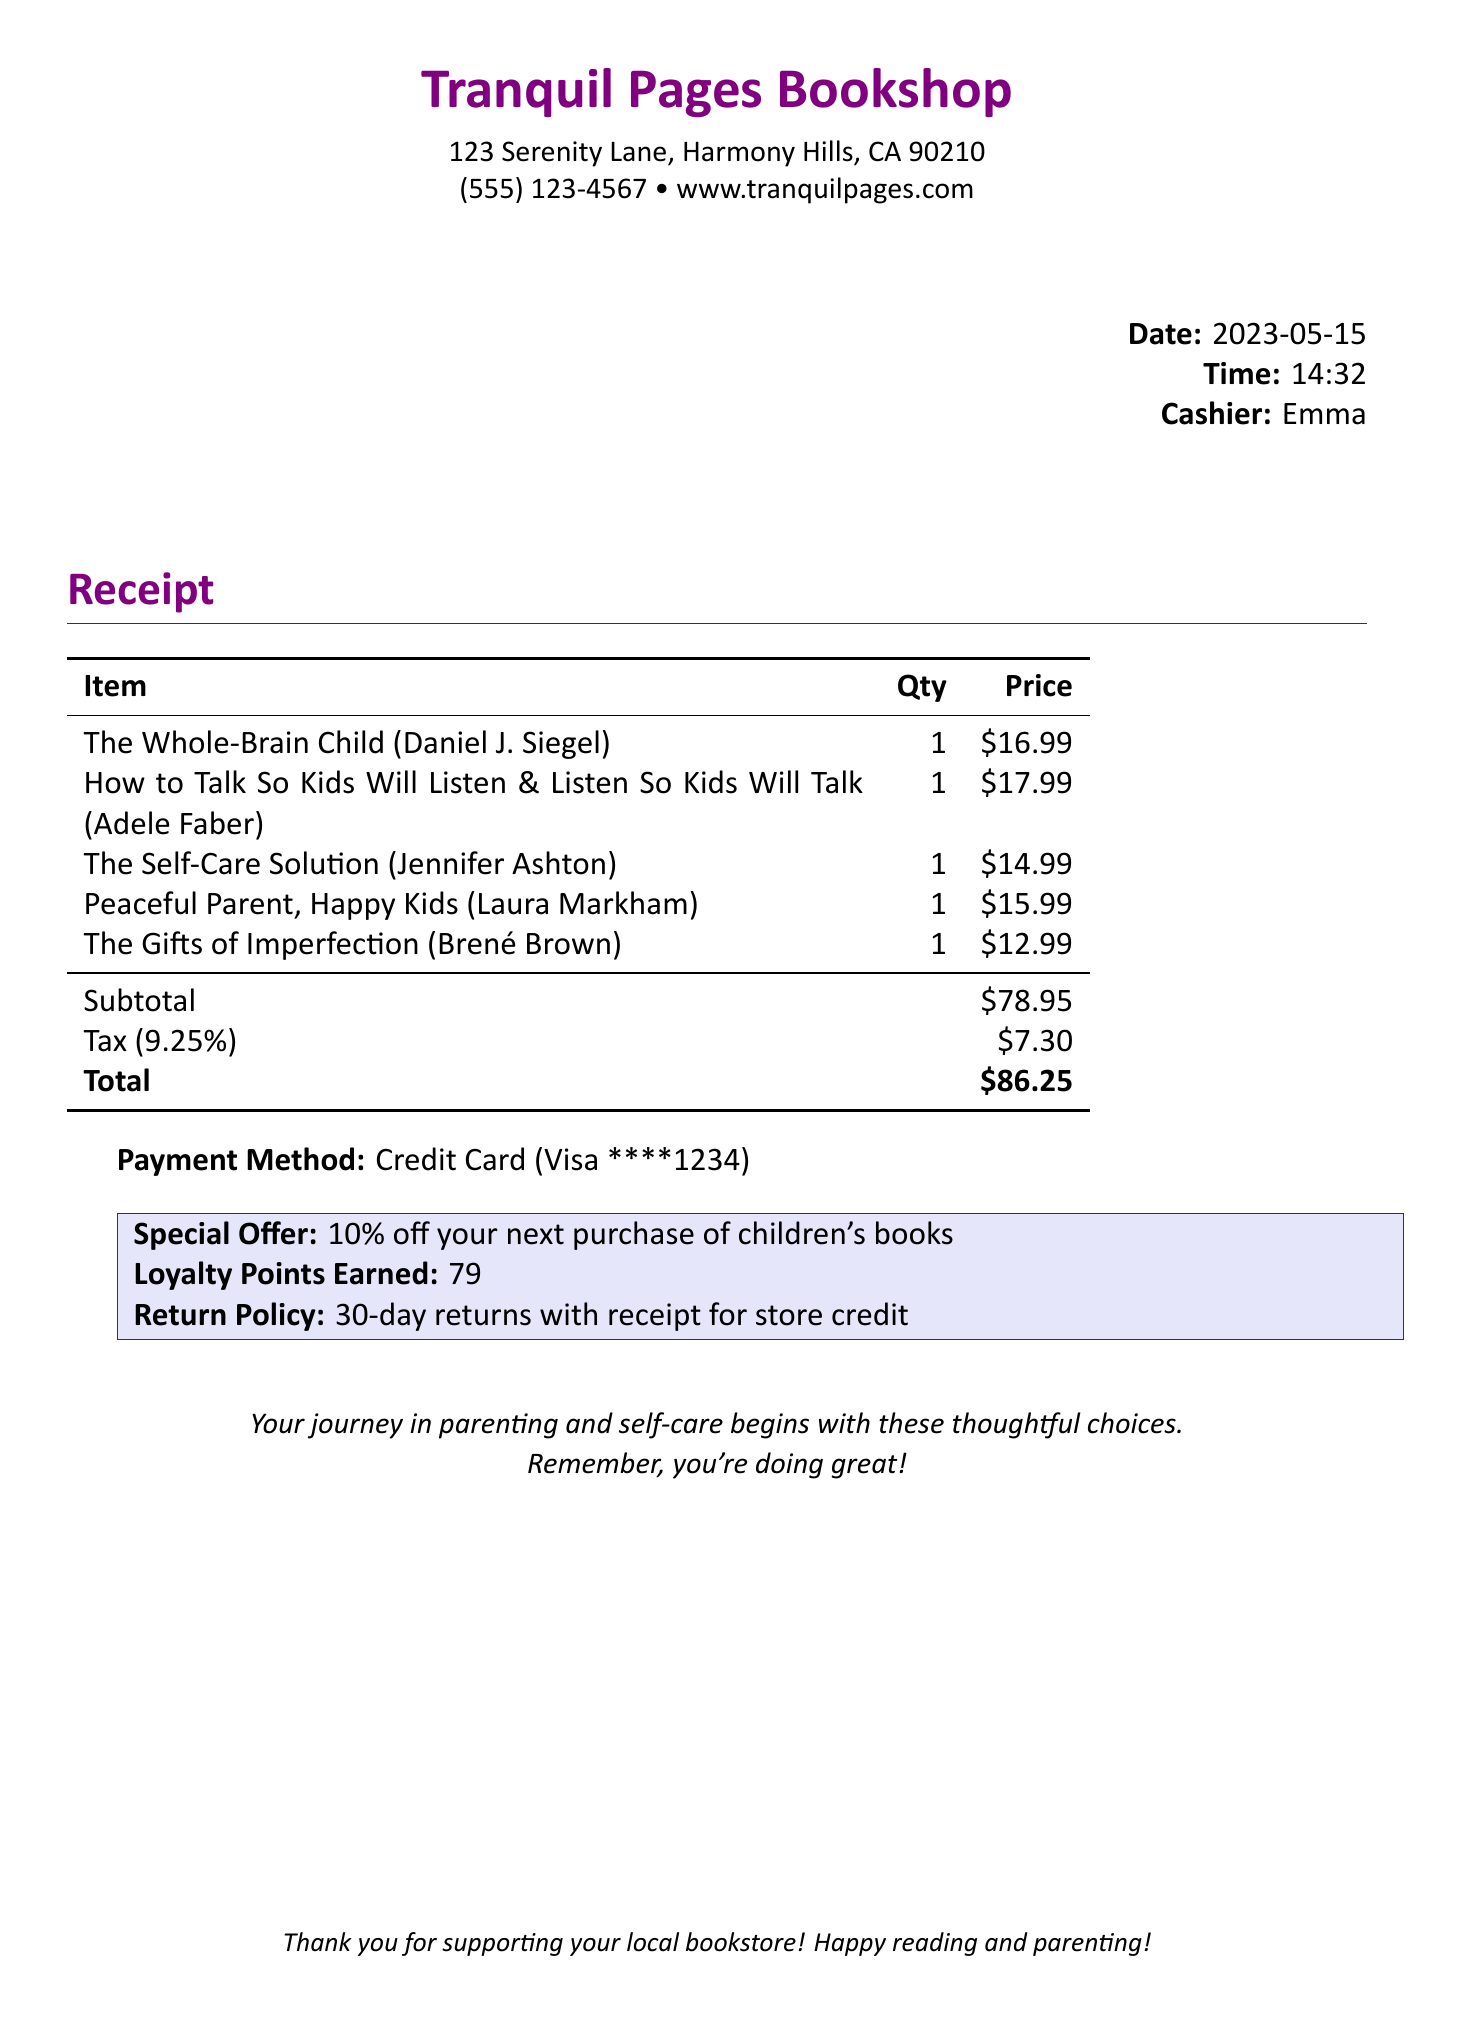What is the name of the bookstore? The name of the bookstore is shown at the top of the receipt.
Answer: Tranquil Pages Bookshop What is the total amount spent? The total amount is indicated in the totals section of the receipt.
Answer: $86.25 Who was the cashier? The cashier's name is stated next to the time on the receipt.
Answer: Emma What date was the purchase made? The purchase date is clearly marked in the receipt details.
Answer: 2023-05-15 What special offer is mentioned? The special offer is specified in the highlighted section of the receipt.
Answer: 10% off your next purchase of children's books What is the tax amount? The tax amount is calculated and shown under the subtotal on the receipt.
Answer: $7.30 How many loyalty points were earned? The receipt mentions the number of loyalty points earned after the purchase.
Answer: 79 What is the return policy? The return policy is noted in the special offer section of the receipt.
Answer: 30-day returns with receipt for store credit What types of books were purchased? The titles on the receipt indicate the types of books bought.
Answer: Parenting and self-help books 